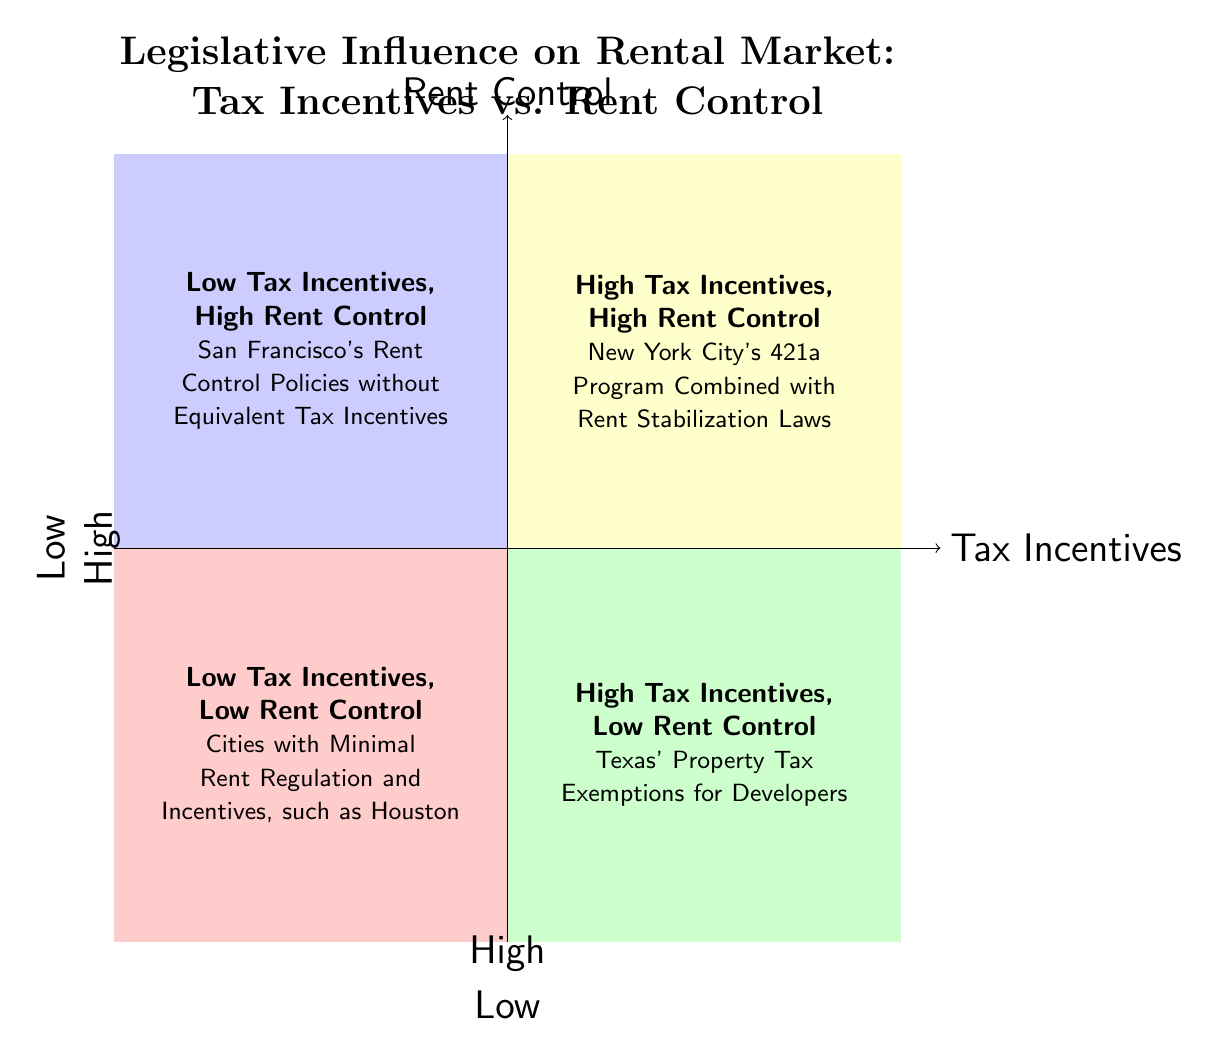What does the top right quadrant represent? The top right quadrant represents the "High Tax Incentives, High Rent Control" scenario, where the government provides significant tax incentives to property developers alongside strict rent control laws.
Answer: High Tax Incentives, High Rent Control Which quadrant is associated with minimal rent regulation and incentives? The bottom left quadrant represents the "Low Tax Incentives, Low Rent Control" scenario, which describes a free-market approach with limited government intervention in taxation and rent regulation.
Answer: Low Tax Incentives, Low Rent Control How many examples are listed in the bottom right quadrant? The bottom right quadrant has one example listed, which is "Texas' Property Tax Exemptions for Developers."
Answer: 1 Which city is listed in the "Low Tax Incentives, High Rent Control" quadrant? San Francisco is mentioned as an example in the "Low Tax Incentives, High Rent Control" quadrant, detailing its rent control policies without equivalent tax incentives.
Answer: San Francisco What is the relationship between tax incentives and rent control in the top left quadrant? In the top left quadrant, the relationship indicates that as tax incentives are low, rent control is high, leading to potential shortages in new housing developments.
Answer: Low Tax Incentives, High Rent Control Which quadrant showcases scenarios with potential market-driven rent prices? The bottom right quadrant exemplifies the "High Tax Incentives, Low Rent Control," where robust tax incentives to developers lead to potential market-driven rent prices.
Answer: High Tax Incentives, Low Rent Control What is the effect of strong rent control with few tax breaks on housing development? The "Low Tax Incentives, High Rent Control" quadrant indicates that strong rent control with few tax breaks could lead to potential shortages in new housing developments.
Answer: Shortages in new housing developments Which quadrant reflects a purely market-driven landscape? The bottom left quadrant illustrates a purely market-driven landscape with "Low Tax Incentives, Low Rent Control," indicating limited government intervention.
Answer: Low Tax Incentives, Low Rent Control 